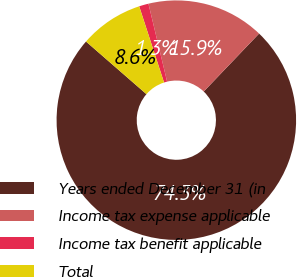Convert chart. <chart><loc_0><loc_0><loc_500><loc_500><pie_chart><fcel>Years ended December 31 (in<fcel>Income tax expense applicable<fcel>Income tax benefit applicable<fcel>Total<nl><fcel>74.27%<fcel>15.88%<fcel>1.28%<fcel>8.58%<nl></chart> 